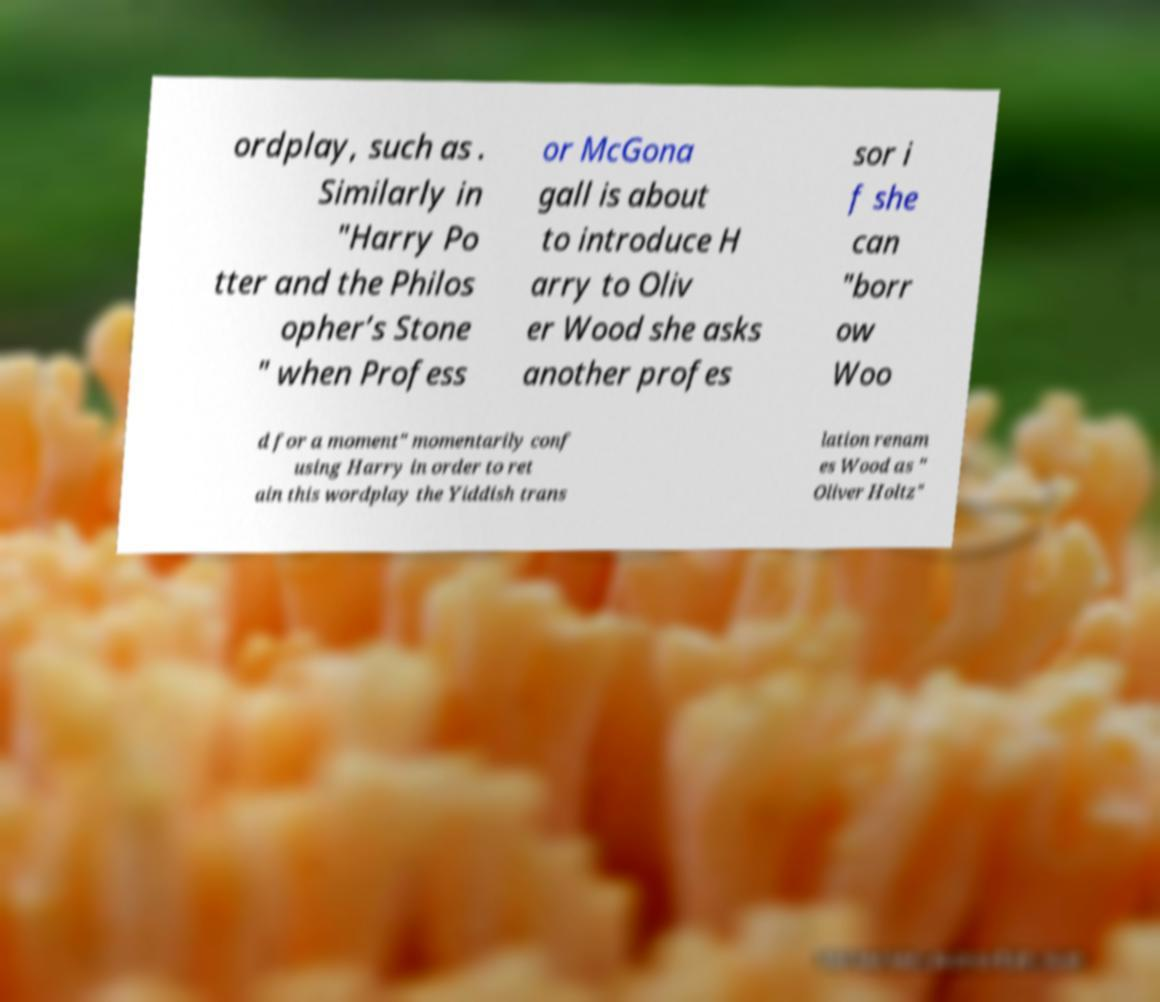What messages or text are displayed in this image? I need them in a readable, typed format. ordplay, such as . Similarly in "Harry Po tter and the Philos opher’s Stone " when Profess or McGona gall is about to introduce H arry to Oliv er Wood she asks another profes sor i f she can "borr ow Woo d for a moment" momentarily conf using Harry in order to ret ain this wordplay the Yiddish trans lation renam es Wood as " Oliver Holtz" 